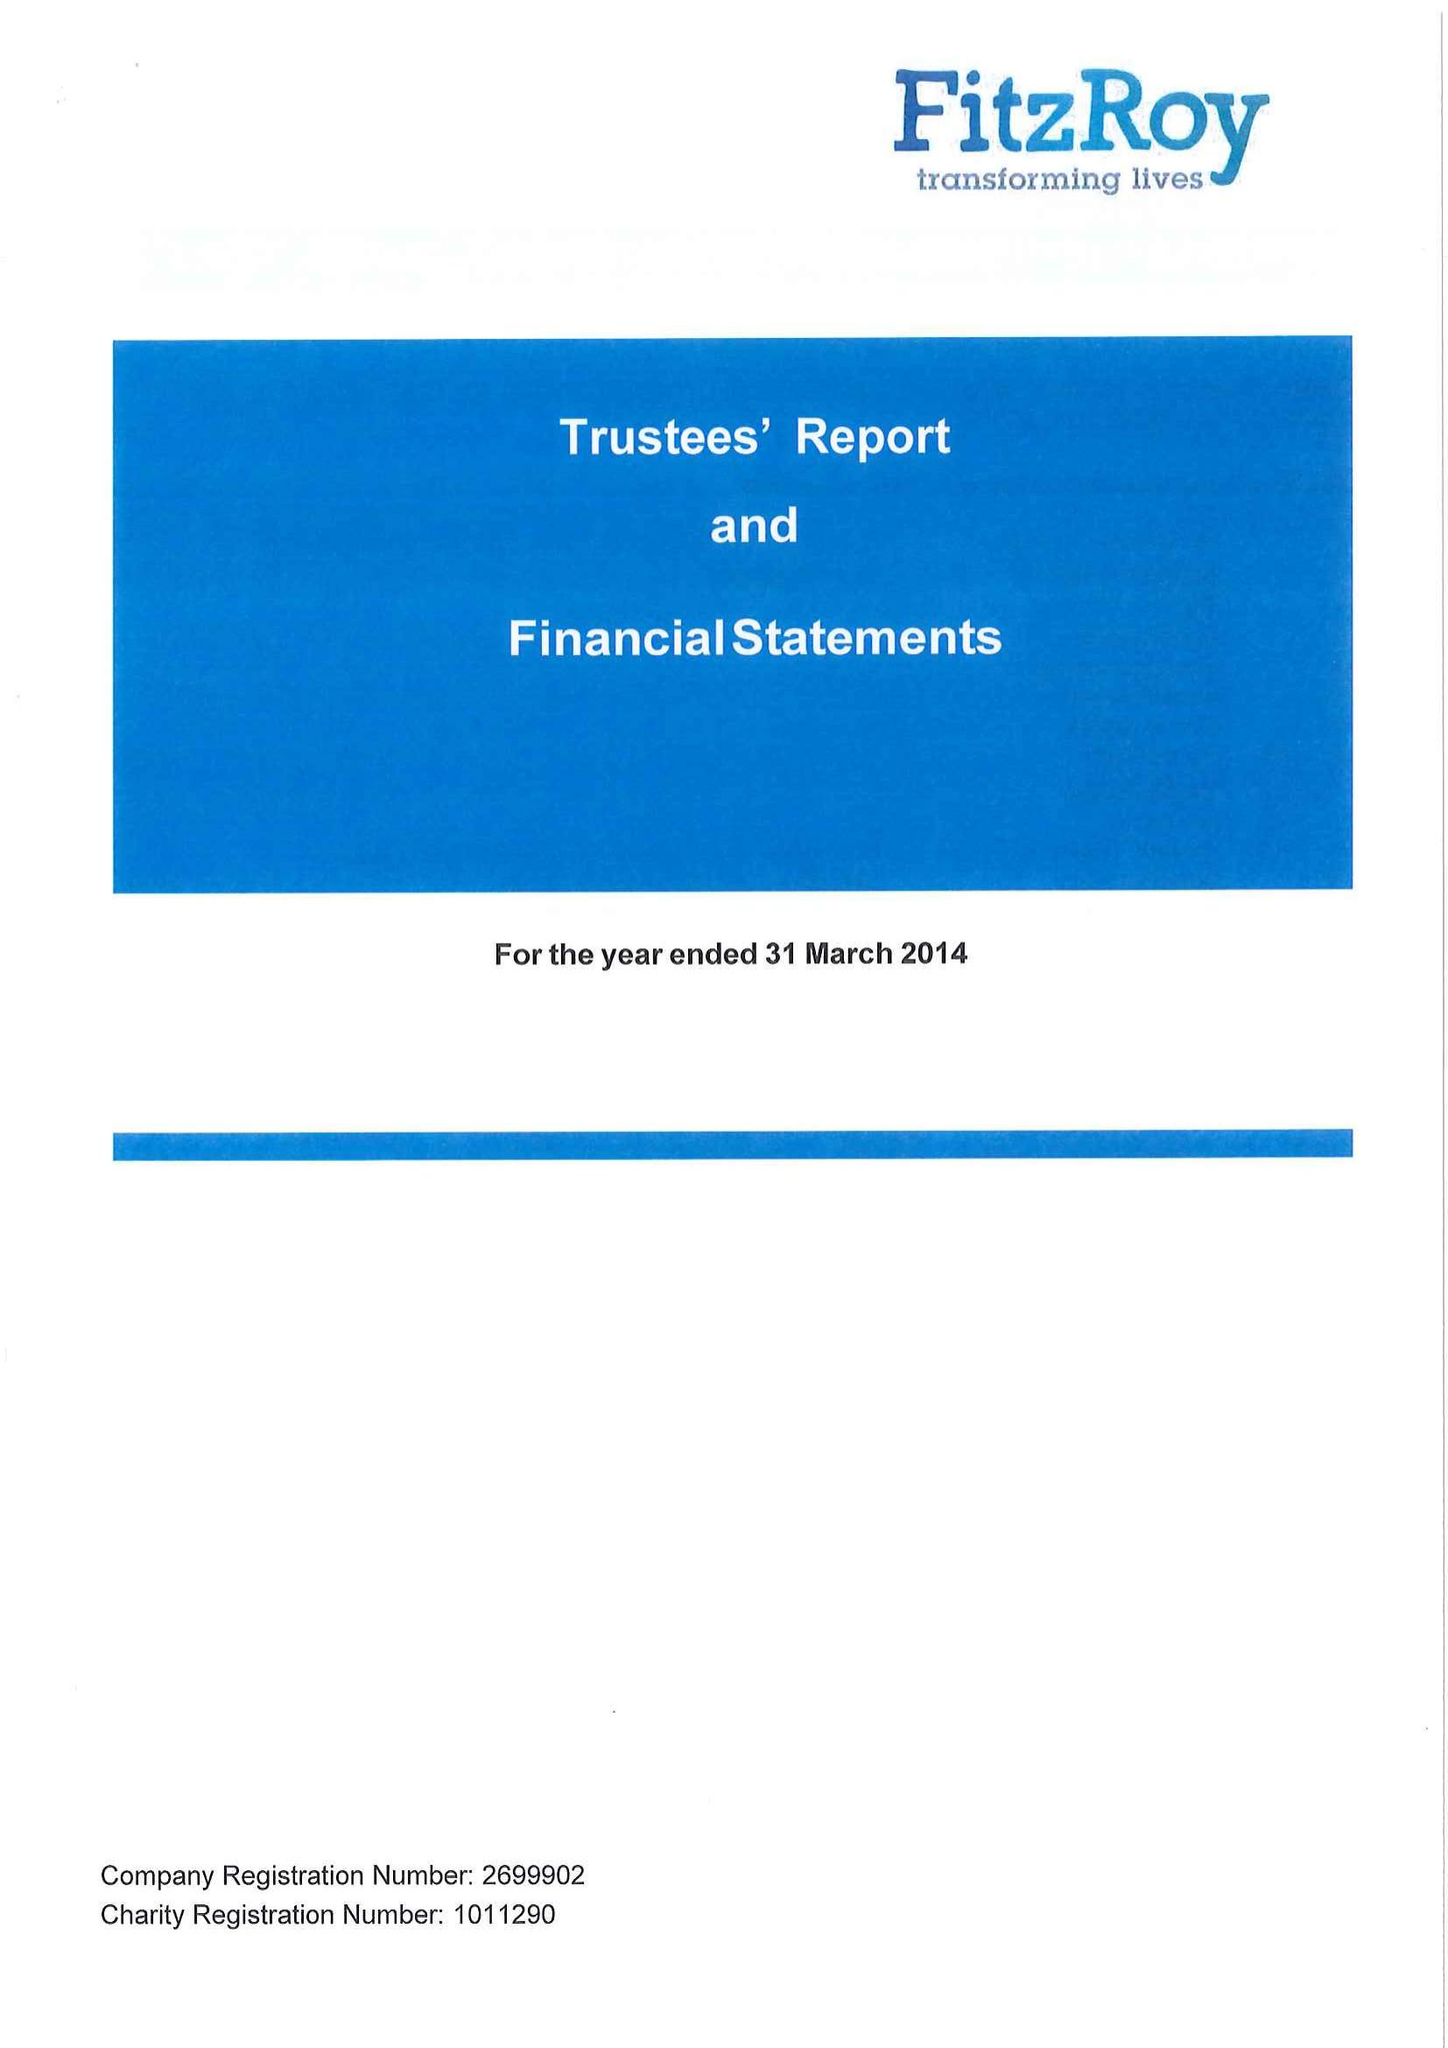What is the value for the spending_annually_in_british_pounds?
Answer the question using a single word or phrase. 22333866.00 